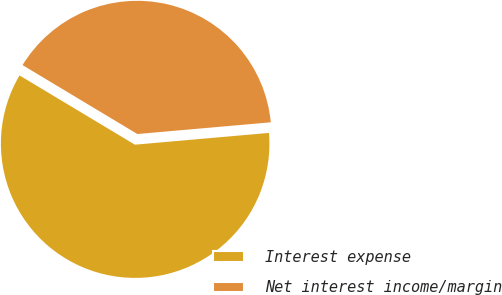<chart> <loc_0><loc_0><loc_500><loc_500><pie_chart><fcel>Interest expense<fcel>Net interest income/margin<nl><fcel>60.0%<fcel>40.0%<nl></chart> 